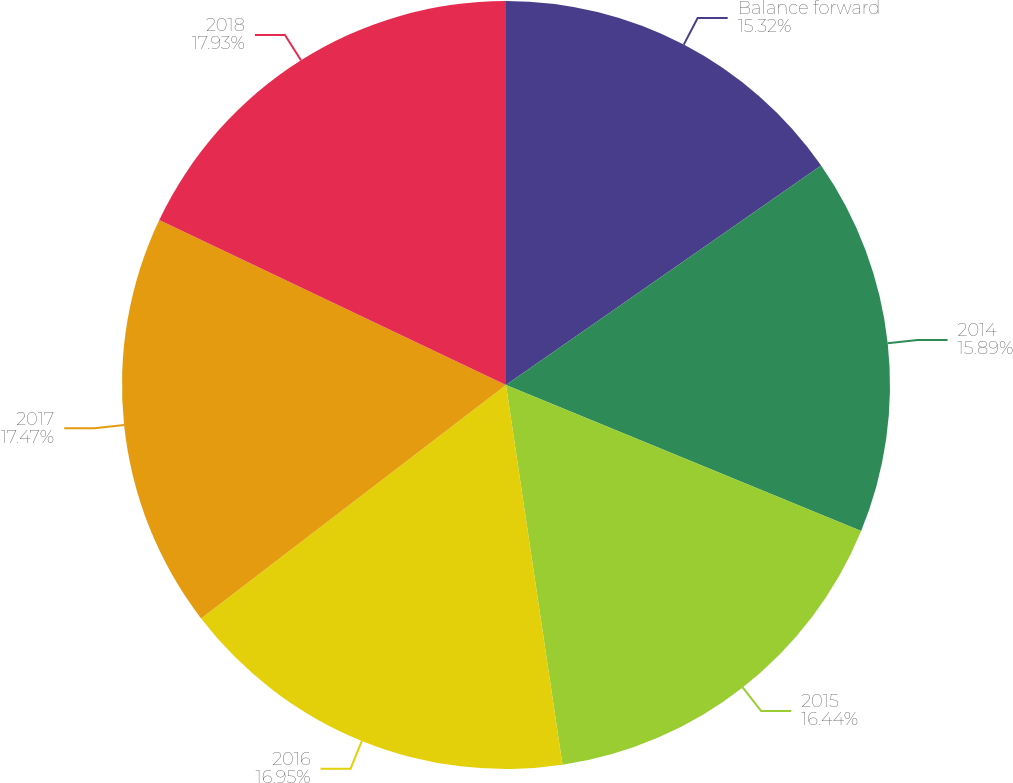Convert chart. <chart><loc_0><loc_0><loc_500><loc_500><pie_chart><fcel>Balance forward<fcel>2014<fcel>2015<fcel>2016<fcel>2017<fcel>2018<nl><fcel>15.32%<fcel>15.89%<fcel>16.44%<fcel>16.95%<fcel>17.47%<fcel>17.93%<nl></chart> 